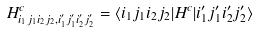Convert formula to latex. <formula><loc_0><loc_0><loc_500><loc_500>H ^ { c } _ { i _ { 1 } j _ { 1 } i _ { 2 } j _ { 2 } , i _ { 1 } ^ { \prime } j _ { 1 } ^ { \prime } i _ { 2 } ^ { \prime } j _ { 2 } ^ { \prime } } = \langle i _ { 1 } j _ { 1 } i _ { 2 } j _ { 2 } | { H } ^ { c } | i _ { 1 } ^ { \prime } j _ { 1 } ^ { \prime } i _ { 2 } ^ { \prime } j _ { 2 } ^ { \prime } \rangle</formula> 